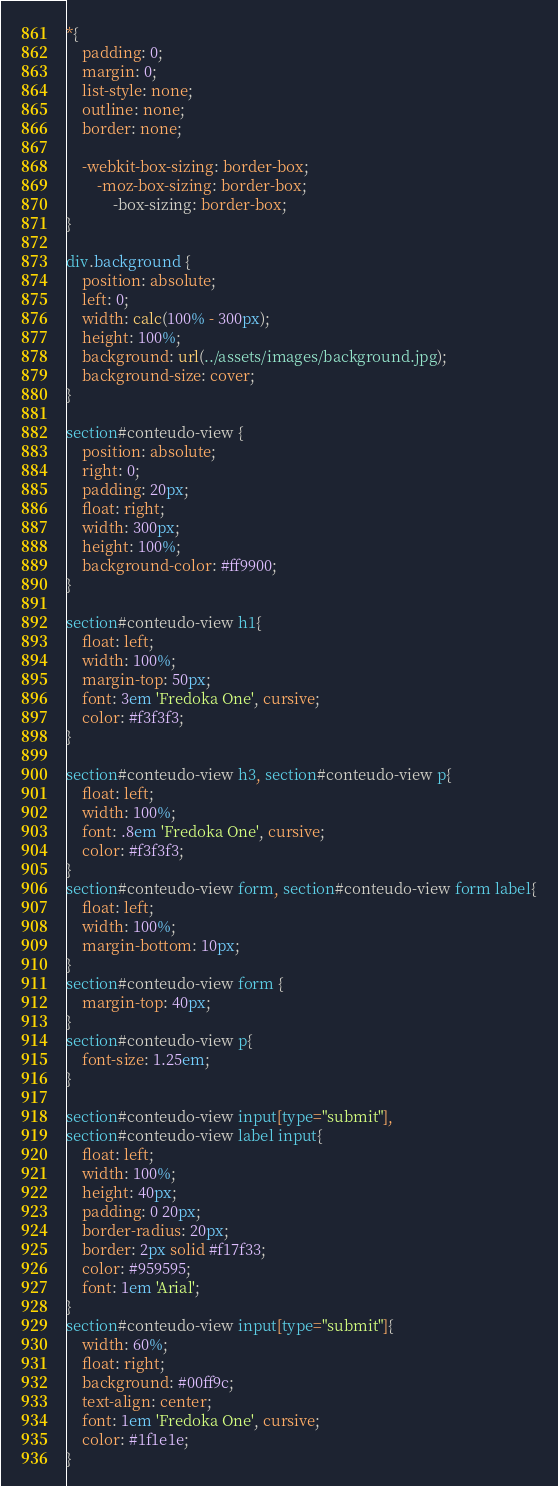Convert code to text. <code><loc_0><loc_0><loc_500><loc_500><_CSS_>*{
    padding: 0;
    margin: 0;
    list-style: none;
    outline: none;
    border: none;

    -webkit-box-sizing: border-box;
        -moz-box-sizing: border-box;
            -box-sizing: border-box;
}

div.background {
    position: absolute;
    left: 0;
    width: calc(100% - 300px);
    height: 100%;
    background: url(../assets/images/background.jpg);
    background-size: cover;
}

section#conteudo-view {
    position: absolute;
    right: 0;
    padding: 20px;
    float: right;
    width: 300px;
    height: 100%;
    background-color: #ff9900;
}

section#conteudo-view h1{
    float: left;
    width: 100%;
    margin-top: 50px;
    font: 3em 'Fredoka One', cursive;
    color: #f3f3f3;
}

section#conteudo-view h3, section#conteudo-view p{
    float: left;
    width: 100%;
    font: .8em 'Fredoka One', cursive;
    color: #f3f3f3;
}
section#conteudo-view form, section#conteudo-view form label{
    float: left;
    width: 100%;
    margin-bottom: 10px;
}
section#conteudo-view form {
    margin-top: 40px;
}
section#conteudo-view p{
    font-size: 1.25em;
}

section#conteudo-view input[type="submit"],
section#conteudo-view label input{
    float: left;
    width: 100%;
    height: 40px;
    padding: 0 20px;
    border-radius: 20px;
    border: 2px solid #f17f33;
    color: #959595;
    font: 1em 'Arial';
}
section#conteudo-view input[type="submit"]{
    width: 60%;
    float: right;
    background: #00ff9c;
    text-align: center;
    font: 1em 'Fredoka One', cursive;
    color: #1f1e1e;
}

</code> 